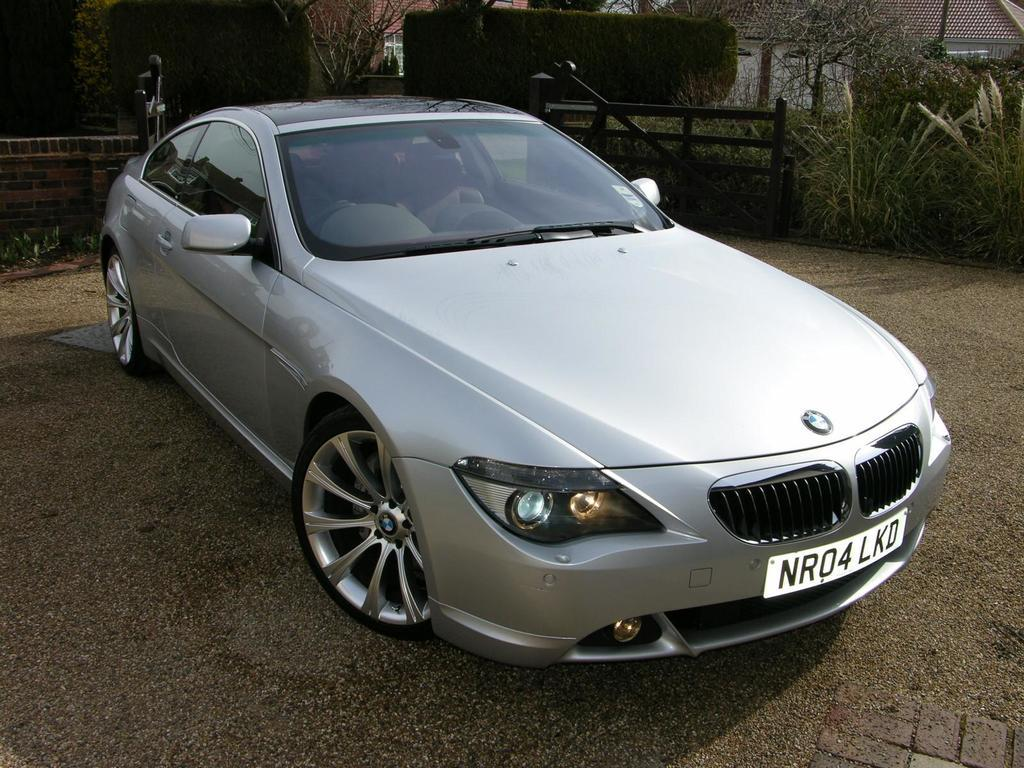What is the main subject of the image? The main subject of the image is a car. Where is the car located in the image? The car is parked on the road surface. What can be seen behind the car in the image? There are trees and houses visible behind the car. What is the brother's throat condition in the image? There is no brother or throat condition mentioned in the image; it only features a car parked on the road surface with trees and houses visible in the background. 